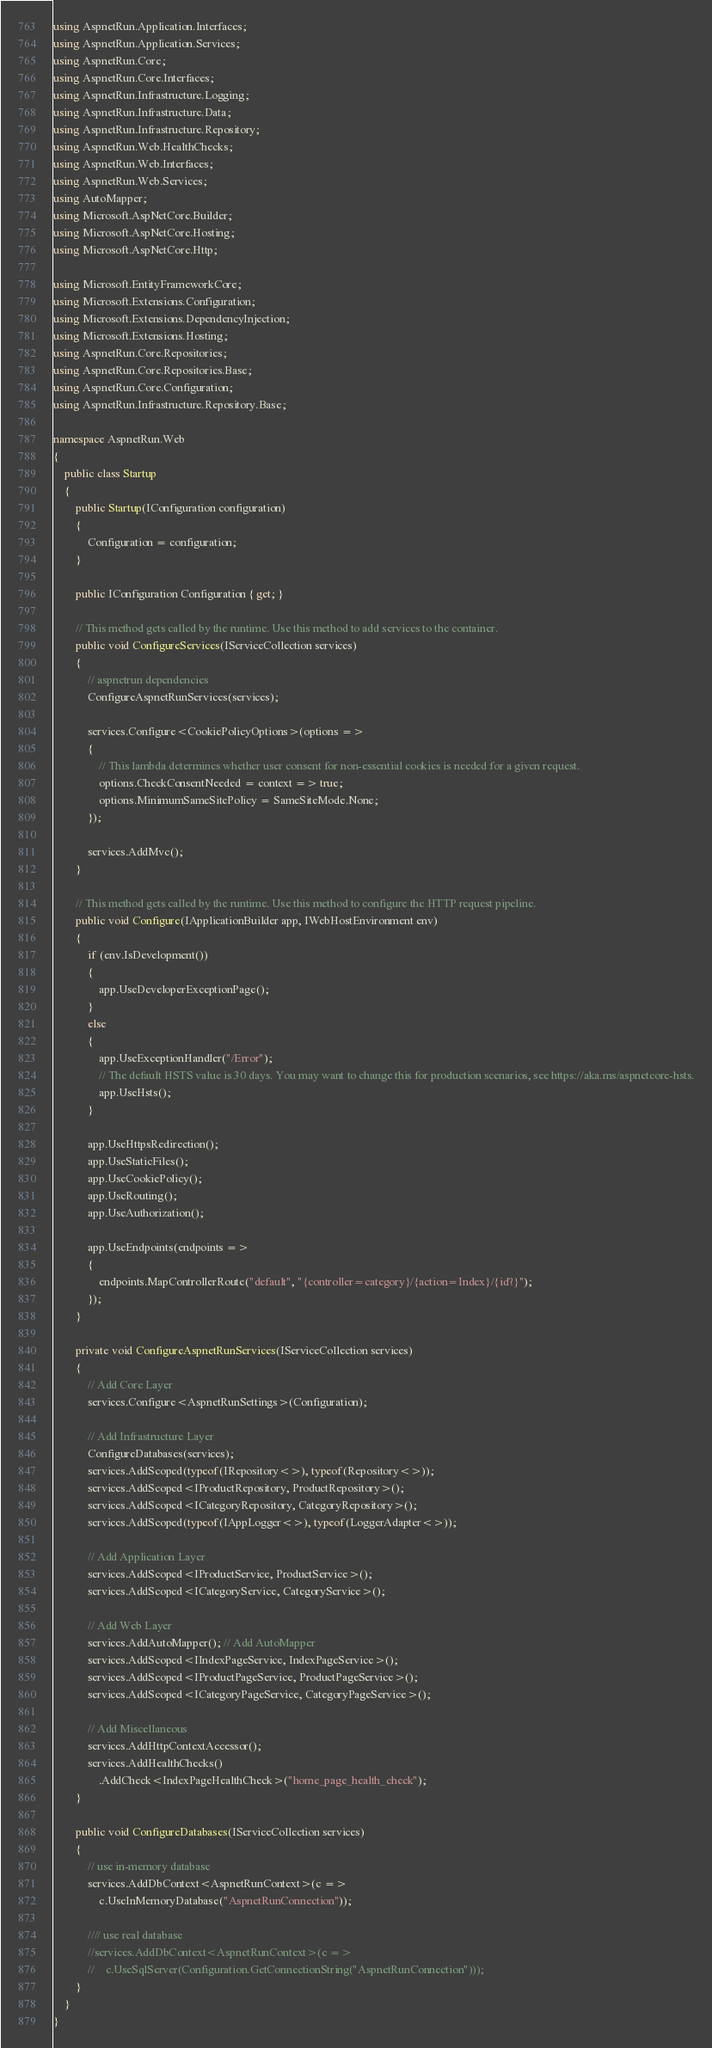<code> <loc_0><loc_0><loc_500><loc_500><_C#_>using AspnetRun.Application.Interfaces;
using AspnetRun.Application.Services;
using AspnetRun.Core;
using AspnetRun.Core.Interfaces;
using AspnetRun.Infrastructure.Logging;
using AspnetRun.Infrastructure.Data;
using AspnetRun.Infrastructure.Repository;
using AspnetRun.Web.HealthChecks;
using AspnetRun.Web.Interfaces;
using AspnetRun.Web.Services;
using AutoMapper;
using Microsoft.AspNetCore.Builder;
using Microsoft.AspNetCore.Hosting;
using Microsoft.AspNetCore.Http;

using Microsoft.EntityFrameworkCore;
using Microsoft.Extensions.Configuration;
using Microsoft.Extensions.DependencyInjection;
using Microsoft.Extensions.Hosting;
using AspnetRun.Core.Repositories;
using AspnetRun.Core.Repositories.Base;
using AspnetRun.Core.Configuration;
using AspnetRun.Infrastructure.Repository.Base;

namespace AspnetRun.Web
{
    public class Startup
    {
        public Startup(IConfiguration configuration)
        {
            Configuration = configuration;
        }

        public IConfiguration Configuration { get; }

        // This method gets called by the runtime. Use this method to add services to the container.
        public void ConfigureServices(IServiceCollection services)
        {            
            // aspnetrun dependencies
            ConfigureAspnetRunServices(services);            

            services.Configure<CookiePolicyOptions>(options =>
            {
                // This lambda determines whether user consent for non-essential cookies is needed for a given request.
                options.CheckConsentNeeded = context => true;
                options.MinimumSameSitePolicy = SameSiteMode.None;
            });

            services.AddMvc();
        }        

        // This method gets called by the runtime. Use this method to configure the HTTP request pipeline.
        public void Configure(IApplicationBuilder app, IWebHostEnvironment env)
        {
            if (env.IsDevelopment())
            {
                app.UseDeveloperExceptionPage();
            }
            else
            {
                app.UseExceptionHandler("/Error");
                // The default HSTS value is 30 days. You may want to change this for production scenarios, see https://aka.ms/aspnetcore-hsts.
                app.UseHsts();
            }

            app.UseHttpsRedirection();
            app.UseStaticFiles();
            app.UseCookiePolicy();
            app.UseRouting();
            app.UseAuthorization();

            app.UseEndpoints(endpoints =>
            {
                endpoints.MapControllerRoute("default", "{controller=category}/{action=Index}/{id?}");
            });
        }

        private void ConfigureAspnetRunServices(IServiceCollection services)
        {
            // Add Core Layer
            services.Configure<AspnetRunSettings>(Configuration);

            // Add Infrastructure Layer
            ConfigureDatabases(services);
            services.AddScoped(typeof(IRepository<>), typeof(Repository<>));
            services.AddScoped<IProductRepository, ProductRepository>();
            services.AddScoped<ICategoryRepository, CategoryRepository>();
            services.AddScoped(typeof(IAppLogger<>), typeof(LoggerAdapter<>));

            // Add Application Layer
            services.AddScoped<IProductService, ProductService>();
            services.AddScoped<ICategoryService, CategoryService>();

            // Add Web Layer
            services.AddAutoMapper(); // Add AutoMapper
            services.AddScoped<IIndexPageService, IndexPageService>();
            services.AddScoped<IProductPageService, ProductPageService>();
            services.AddScoped<ICategoryPageService, CategoryPageService>();

            // Add Miscellaneous
            services.AddHttpContextAccessor();
            services.AddHealthChecks()
                .AddCheck<IndexPageHealthCheck>("home_page_health_check");
        }

        public void ConfigureDatabases(IServiceCollection services)
        {
            // use in-memory database
            services.AddDbContext<AspnetRunContext>(c =>
                c.UseInMemoryDatabase("AspnetRunConnection"));

            //// use real database
            //services.AddDbContext<AspnetRunContext>(c =>
            //    c.UseSqlServer(Configuration.GetConnectionString("AspnetRunConnection")));
        }
    }
}
</code> 